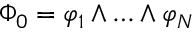Convert formula to latex. <formula><loc_0><loc_0><loc_500><loc_500>\Phi _ { 0 } = \varphi _ { 1 } \wedge \dots \wedge \varphi _ { N }</formula> 